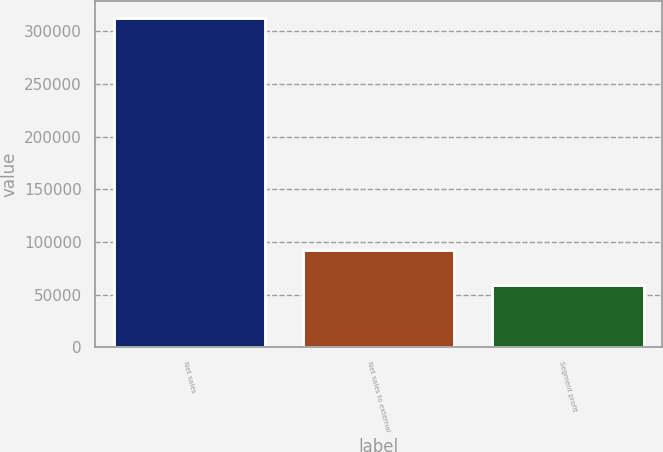Convert chart to OTSL. <chart><loc_0><loc_0><loc_500><loc_500><bar_chart><fcel>Net sales<fcel>Net sales to external<fcel>Segment profit<nl><fcel>312992<fcel>92321<fcel>59576<nl></chart> 